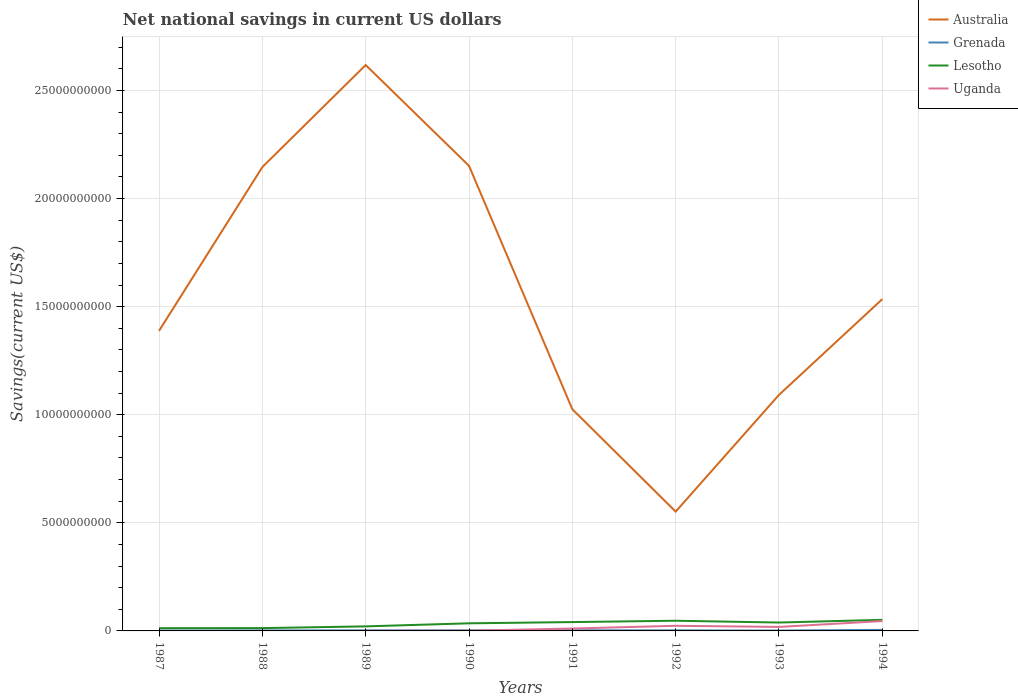Does the line corresponding to Australia intersect with the line corresponding to Uganda?
Give a very brief answer. No. Across all years, what is the maximum net national savings in Grenada?
Make the answer very short. 1.82e+07. What is the total net national savings in Grenada in the graph?
Keep it short and to the point. 7.77e+06. What is the difference between the highest and the second highest net national savings in Lesotho?
Keep it short and to the point. 3.85e+08. What is the difference between the highest and the lowest net national savings in Grenada?
Your response must be concise. 2. What is the difference between two consecutive major ticks on the Y-axis?
Provide a short and direct response. 5.00e+09. Are the values on the major ticks of Y-axis written in scientific E-notation?
Ensure brevity in your answer.  No. Does the graph contain grids?
Offer a terse response. Yes. Where does the legend appear in the graph?
Your response must be concise. Top right. How many legend labels are there?
Keep it short and to the point. 4. What is the title of the graph?
Your response must be concise. Net national savings in current US dollars. What is the label or title of the Y-axis?
Provide a succinct answer. Savings(current US$). What is the Savings(current US$) in Australia in 1987?
Ensure brevity in your answer.  1.39e+1. What is the Savings(current US$) in Grenada in 1987?
Provide a short and direct response. 1.85e+07. What is the Savings(current US$) of Lesotho in 1987?
Give a very brief answer. 1.28e+08. What is the Savings(current US$) of Uganda in 1987?
Your answer should be compact. 0. What is the Savings(current US$) of Australia in 1988?
Keep it short and to the point. 2.15e+1. What is the Savings(current US$) of Grenada in 1988?
Offer a terse response. 2.32e+07. What is the Savings(current US$) in Lesotho in 1988?
Provide a short and direct response. 1.30e+08. What is the Savings(current US$) of Uganda in 1988?
Your answer should be compact. 0. What is the Savings(current US$) of Australia in 1989?
Provide a succinct answer. 2.62e+1. What is the Savings(current US$) of Grenada in 1989?
Your answer should be compact. 2.59e+07. What is the Savings(current US$) of Lesotho in 1989?
Your answer should be compact. 2.10e+08. What is the Savings(current US$) of Uganda in 1989?
Give a very brief answer. 5.49e+06. What is the Savings(current US$) in Australia in 1990?
Offer a terse response. 2.15e+1. What is the Savings(current US$) in Grenada in 1990?
Provide a short and direct response. 2.65e+07. What is the Savings(current US$) of Lesotho in 1990?
Offer a very short reply. 3.52e+08. What is the Savings(current US$) in Uganda in 1990?
Your response must be concise. 1.02e+07. What is the Savings(current US$) of Australia in 1991?
Keep it short and to the point. 1.03e+1. What is the Savings(current US$) of Grenada in 1991?
Provide a short and direct response. 3.05e+07. What is the Savings(current US$) of Lesotho in 1991?
Provide a succinct answer. 4.09e+08. What is the Savings(current US$) in Uganda in 1991?
Your response must be concise. 1.10e+08. What is the Savings(current US$) of Australia in 1992?
Your answer should be compact. 5.52e+09. What is the Savings(current US$) of Grenada in 1992?
Your answer should be compact. 2.60e+07. What is the Savings(current US$) in Lesotho in 1992?
Provide a succinct answer. 4.71e+08. What is the Savings(current US$) of Uganda in 1992?
Keep it short and to the point. 2.37e+08. What is the Savings(current US$) in Australia in 1993?
Your response must be concise. 1.09e+1. What is the Savings(current US$) of Grenada in 1993?
Provide a short and direct response. 1.82e+07. What is the Savings(current US$) of Lesotho in 1993?
Offer a terse response. 3.88e+08. What is the Savings(current US$) in Uganda in 1993?
Make the answer very short. 1.85e+08. What is the Savings(current US$) of Australia in 1994?
Provide a short and direct response. 1.53e+1. What is the Savings(current US$) of Grenada in 1994?
Make the answer very short. 4.84e+07. What is the Savings(current US$) of Lesotho in 1994?
Offer a very short reply. 5.12e+08. What is the Savings(current US$) of Uganda in 1994?
Your answer should be compact. 4.56e+08. Across all years, what is the maximum Savings(current US$) in Australia?
Keep it short and to the point. 2.62e+1. Across all years, what is the maximum Savings(current US$) in Grenada?
Give a very brief answer. 4.84e+07. Across all years, what is the maximum Savings(current US$) in Lesotho?
Ensure brevity in your answer.  5.12e+08. Across all years, what is the maximum Savings(current US$) of Uganda?
Offer a very short reply. 4.56e+08. Across all years, what is the minimum Savings(current US$) in Australia?
Ensure brevity in your answer.  5.52e+09. Across all years, what is the minimum Savings(current US$) of Grenada?
Give a very brief answer. 1.82e+07. Across all years, what is the minimum Savings(current US$) in Lesotho?
Provide a succinct answer. 1.28e+08. Across all years, what is the minimum Savings(current US$) of Uganda?
Ensure brevity in your answer.  0. What is the total Savings(current US$) in Australia in the graph?
Provide a succinct answer. 1.25e+11. What is the total Savings(current US$) of Grenada in the graph?
Provide a short and direct response. 2.17e+08. What is the total Savings(current US$) in Lesotho in the graph?
Your answer should be compact. 2.60e+09. What is the total Savings(current US$) in Uganda in the graph?
Make the answer very short. 1.00e+09. What is the difference between the Savings(current US$) of Australia in 1987 and that in 1988?
Provide a short and direct response. -7.58e+09. What is the difference between the Savings(current US$) of Grenada in 1987 and that in 1988?
Offer a terse response. -4.69e+06. What is the difference between the Savings(current US$) in Lesotho in 1987 and that in 1988?
Make the answer very short. -2.21e+06. What is the difference between the Savings(current US$) in Australia in 1987 and that in 1989?
Ensure brevity in your answer.  -1.23e+1. What is the difference between the Savings(current US$) in Grenada in 1987 and that in 1989?
Make the answer very short. -7.41e+06. What is the difference between the Savings(current US$) in Lesotho in 1987 and that in 1989?
Ensure brevity in your answer.  -8.29e+07. What is the difference between the Savings(current US$) of Australia in 1987 and that in 1990?
Your answer should be compact. -7.63e+09. What is the difference between the Savings(current US$) of Grenada in 1987 and that in 1990?
Your answer should be compact. -8.00e+06. What is the difference between the Savings(current US$) in Lesotho in 1987 and that in 1990?
Make the answer very short. -2.24e+08. What is the difference between the Savings(current US$) in Australia in 1987 and that in 1991?
Your answer should be very brief. 3.62e+09. What is the difference between the Savings(current US$) in Grenada in 1987 and that in 1991?
Offer a terse response. -1.20e+07. What is the difference between the Savings(current US$) in Lesotho in 1987 and that in 1991?
Your answer should be very brief. -2.82e+08. What is the difference between the Savings(current US$) of Australia in 1987 and that in 1992?
Provide a short and direct response. 8.36e+09. What is the difference between the Savings(current US$) in Grenada in 1987 and that in 1992?
Give a very brief answer. -7.45e+06. What is the difference between the Savings(current US$) in Lesotho in 1987 and that in 1992?
Provide a succinct answer. -3.44e+08. What is the difference between the Savings(current US$) in Australia in 1987 and that in 1993?
Ensure brevity in your answer.  2.96e+09. What is the difference between the Savings(current US$) in Grenada in 1987 and that in 1993?
Your answer should be very brief. 3.14e+05. What is the difference between the Savings(current US$) of Lesotho in 1987 and that in 1993?
Offer a very short reply. -2.61e+08. What is the difference between the Savings(current US$) of Australia in 1987 and that in 1994?
Make the answer very short. -1.47e+09. What is the difference between the Savings(current US$) of Grenada in 1987 and that in 1994?
Offer a very short reply. -2.99e+07. What is the difference between the Savings(current US$) in Lesotho in 1987 and that in 1994?
Ensure brevity in your answer.  -3.85e+08. What is the difference between the Savings(current US$) in Australia in 1988 and that in 1989?
Provide a succinct answer. -4.72e+09. What is the difference between the Savings(current US$) of Grenada in 1988 and that in 1989?
Offer a terse response. -2.72e+06. What is the difference between the Savings(current US$) in Lesotho in 1988 and that in 1989?
Your answer should be very brief. -8.07e+07. What is the difference between the Savings(current US$) of Australia in 1988 and that in 1990?
Your answer should be compact. -5.80e+07. What is the difference between the Savings(current US$) in Grenada in 1988 and that in 1990?
Give a very brief answer. -3.31e+06. What is the difference between the Savings(current US$) of Lesotho in 1988 and that in 1990?
Provide a short and direct response. -2.22e+08. What is the difference between the Savings(current US$) in Australia in 1988 and that in 1991?
Your response must be concise. 1.12e+1. What is the difference between the Savings(current US$) in Grenada in 1988 and that in 1991?
Keep it short and to the point. -7.28e+06. What is the difference between the Savings(current US$) in Lesotho in 1988 and that in 1991?
Your answer should be compact. -2.80e+08. What is the difference between the Savings(current US$) in Australia in 1988 and that in 1992?
Your answer should be compact. 1.59e+1. What is the difference between the Savings(current US$) of Grenada in 1988 and that in 1992?
Your answer should be compact. -2.76e+06. What is the difference between the Savings(current US$) of Lesotho in 1988 and that in 1992?
Keep it short and to the point. -3.42e+08. What is the difference between the Savings(current US$) in Australia in 1988 and that in 1993?
Give a very brief answer. 1.05e+1. What is the difference between the Savings(current US$) in Grenada in 1988 and that in 1993?
Provide a short and direct response. 5.00e+06. What is the difference between the Savings(current US$) of Lesotho in 1988 and that in 1993?
Your answer should be very brief. -2.59e+08. What is the difference between the Savings(current US$) of Australia in 1988 and that in 1994?
Ensure brevity in your answer.  6.11e+09. What is the difference between the Savings(current US$) of Grenada in 1988 and that in 1994?
Offer a very short reply. -2.52e+07. What is the difference between the Savings(current US$) of Lesotho in 1988 and that in 1994?
Keep it short and to the point. -3.83e+08. What is the difference between the Savings(current US$) of Australia in 1989 and that in 1990?
Your answer should be compact. 4.66e+09. What is the difference between the Savings(current US$) of Grenada in 1989 and that in 1990?
Ensure brevity in your answer.  -5.96e+05. What is the difference between the Savings(current US$) of Lesotho in 1989 and that in 1990?
Keep it short and to the point. -1.41e+08. What is the difference between the Savings(current US$) in Uganda in 1989 and that in 1990?
Your answer should be very brief. -4.75e+06. What is the difference between the Savings(current US$) of Australia in 1989 and that in 1991?
Keep it short and to the point. 1.59e+1. What is the difference between the Savings(current US$) in Grenada in 1989 and that in 1991?
Your response must be concise. -4.56e+06. What is the difference between the Savings(current US$) of Lesotho in 1989 and that in 1991?
Offer a terse response. -1.99e+08. What is the difference between the Savings(current US$) in Uganda in 1989 and that in 1991?
Your response must be concise. -1.05e+08. What is the difference between the Savings(current US$) of Australia in 1989 and that in 1992?
Provide a succinct answer. 2.07e+1. What is the difference between the Savings(current US$) in Grenada in 1989 and that in 1992?
Offer a terse response. -4.77e+04. What is the difference between the Savings(current US$) in Lesotho in 1989 and that in 1992?
Ensure brevity in your answer.  -2.61e+08. What is the difference between the Savings(current US$) of Uganda in 1989 and that in 1992?
Offer a very short reply. -2.31e+08. What is the difference between the Savings(current US$) in Australia in 1989 and that in 1993?
Provide a succinct answer. 1.53e+1. What is the difference between the Savings(current US$) of Grenada in 1989 and that in 1993?
Ensure brevity in your answer.  7.72e+06. What is the difference between the Savings(current US$) in Lesotho in 1989 and that in 1993?
Offer a terse response. -1.78e+08. What is the difference between the Savings(current US$) in Uganda in 1989 and that in 1993?
Make the answer very short. -1.79e+08. What is the difference between the Savings(current US$) in Australia in 1989 and that in 1994?
Make the answer very short. 1.08e+1. What is the difference between the Savings(current US$) of Grenada in 1989 and that in 1994?
Keep it short and to the point. -2.25e+07. What is the difference between the Savings(current US$) in Lesotho in 1989 and that in 1994?
Provide a short and direct response. -3.02e+08. What is the difference between the Savings(current US$) in Uganda in 1989 and that in 1994?
Ensure brevity in your answer.  -4.51e+08. What is the difference between the Savings(current US$) of Australia in 1990 and that in 1991?
Provide a short and direct response. 1.13e+1. What is the difference between the Savings(current US$) in Grenada in 1990 and that in 1991?
Your answer should be very brief. -3.96e+06. What is the difference between the Savings(current US$) of Lesotho in 1990 and that in 1991?
Give a very brief answer. -5.76e+07. What is the difference between the Savings(current US$) in Uganda in 1990 and that in 1991?
Offer a very short reply. -1.00e+08. What is the difference between the Savings(current US$) of Australia in 1990 and that in 1992?
Make the answer very short. 1.60e+1. What is the difference between the Savings(current US$) of Grenada in 1990 and that in 1992?
Provide a succinct answer. 5.48e+05. What is the difference between the Savings(current US$) in Lesotho in 1990 and that in 1992?
Make the answer very short. -1.20e+08. What is the difference between the Savings(current US$) in Uganda in 1990 and that in 1992?
Your response must be concise. -2.26e+08. What is the difference between the Savings(current US$) of Australia in 1990 and that in 1993?
Your answer should be compact. 1.06e+1. What is the difference between the Savings(current US$) in Grenada in 1990 and that in 1993?
Your response must be concise. 8.32e+06. What is the difference between the Savings(current US$) of Lesotho in 1990 and that in 1993?
Your response must be concise. -3.65e+07. What is the difference between the Savings(current US$) of Uganda in 1990 and that in 1993?
Make the answer very short. -1.74e+08. What is the difference between the Savings(current US$) in Australia in 1990 and that in 1994?
Offer a terse response. 6.17e+09. What is the difference between the Savings(current US$) in Grenada in 1990 and that in 1994?
Offer a terse response. -2.19e+07. What is the difference between the Savings(current US$) in Lesotho in 1990 and that in 1994?
Your answer should be very brief. -1.61e+08. What is the difference between the Savings(current US$) in Uganda in 1990 and that in 1994?
Provide a short and direct response. -4.46e+08. What is the difference between the Savings(current US$) of Australia in 1991 and that in 1992?
Offer a terse response. 4.74e+09. What is the difference between the Savings(current US$) of Grenada in 1991 and that in 1992?
Provide a succinct answer. 4.51e+06. What is the difference between the Savings(current US$) in Lesotho in 1991 and that in 1992?
Provide a short and direct response. -6.21e+07. What is the difference between the Savings(current US$) in Uganda in 1991 and that in 1992?
Make the answer very short. -1.26e+08. What is the difference between the Savings(current US$) of Australia in 1991 and that in 1993?
Ensure brevity in your answer.  -6.64e+08. What is the difference between the Savings(current US$) of Grenada in 1991 and that in 1993?
Give a very brief answer. 1.23e+07. What is the difference between the Savings(current US$) of Lesotho in 1991 and that in 1993?
Ensure brevity in your answer.  2.10e+07. What is the difference between the Savings(current US$) in Uganda in 1991 and that in 1993?
Provide a short and direct response. -7.42e+07. What is the difference between the Savings(current US$) of Australia in 1991 and that in 1994?
Offer a terse response. -5.09e+09. What is the difference between the Savings(current US$) in Grenada in 1991 and that in 1994?
Make the answer very short. -1.79e+07. What is the difference between the Savings(current US$) in Lesotho in 1991 and that in 1994?
Give a very brief answer. -1.03e+08. What is the difference between the Savings(current US$) of Uganda in 1991 and that in 1994?
Make the answer very short. -3.46e+08. What is the difference between the Savings(current US$) in Australia in 1992 and that in 1993?
Your answer should be very brief. -5.40e+09. What is the difference between the Savings(current US$) in Grenada in 1992 and that in 1993?
Your response must be concise. 7.77e+06. What is the difference between the Savings(current US$) of Lesotho in 1992 and that in 1993?
Keep it short and to the point. 8.32e+07. What is the difference between the Savings(current US$) in Uganda in 1992 and that in 1993?
Offer a terse response. 5.19e+07. What is the difference between the Savings(current US$) of Australia in 1992 and that in 1994?
Ensure brevity in your answer.  -9.83e+09. What is the difference between the Savings(current US$) of Grenada in 1992 and that in 1994?
Your response must be concise. -2.24e+07. What is the difference between the Savings(current US$) of Lesotho in 1992 and that in 1994?
Your answer should be very brief. -4.09e+07. What is the difference between the Savings(current US$) of Uganda in 1992 and that in 1994?
Offer a very short reply. -2.20e+08. What is the difference between the Savings(current US$) in Australia in 1993 and that in 1994?
Make the answer very short. -4.43e+09. What is the difference between the Savings(current US$) in Grenada in 1993 and that in 1994?
Offer a very short reply. -3.02e+07. What is the difference between the Savings(current US$) of Lesotho in 1993 and that in 1994?
Give a very brief answer. -1.24e+08. What is the difference between the Savings(current US$) in Uganda in 1993 and that in 1994?
Ensure brevity in your answer.  -2.72e+08. What is the difference between the Savings(current US$) in Australia in 1987 and the Savings(current US$) in Grenada in 1988?
Provide a succinct answer. 1.39e+1. What is the difference between the Savings(current US$) of Australia in 1987 and the Savings(current US$) of Lesotho in 1988?
Provide a short and direct response. 1.37e+1. What is the difference between the Savings(current US$) in Grenada in 1987 and the Savings(current US$) in Lesotho in 1988?
Keep it short and to the point. -1.11e+08. What is the difference between the Savings(current US$) in Australia in 1987 and the Savings(current US$) in Grenada in 1989?
Ensure brevity in your answer.  1.39e+1. What is the difference between the Savings(current US$) in Australia in 1987 and the Savings(current US$) in Lesotho in 1989?
Keep it short and to the point. 1.37e+1. What is the difference between the Savings(current US$) of Australia in 1987 and the Savings(current US$) of Uganda in 1989?
Keep it short and to the point. 1.39e+1. What is the difference between the Savings(current US$) in Grenada in 1987 and the Savings(current US$) in Lesotho in 1989?
Make the answer very short. -1.92e+08. What is the difference between the Savings(current US$) in Grenada in 1987 and the Savings(current US$) in Uganda in 1989?
Keep it short and to the point. 1.30e+07. What is the difference between the Savings(current US$) of Lesotho in 1987 and the Savings(current US$) of Uganda in 1989?
Your response must be concise. 1.22e+08. What is the difference between the Savings(current US$) of Australia in 1987 and the Savings(current US$) of Grenada in 1990?
Your answer should be very brief. 1.39e+1. What is the difference between the Savings(current US$) in Australia in 1987 and the Savings(current US$) in Lesotho in 1990?
Your answer should be compact. 1.35e+1. What is the difference between the Savings(current US$) of Australia in 1987 and the Savings(current US$) of Uganda in 1990?
Keep it short and to the point. 1.39e+1. What is the difference between the Savings(current US$) of Grenada in 1987 and the Savings(current US$) of Lesotho in 1990?
Keep it short and to the point. -3.33e+08. What is the difference between the Savings(current US$) in Grenada in 1987 and the Savings(current US$) in Uganda in 1990?
Provide a short and direct response. 8.27e+06. What is the difference between the Savings(current US$) in Lesotho in 1987 and the Savings(current US$) in Uganda in 1990?
Provide a short and direct response. 1.17e+08. What is the difference between the Savings(current US$) of Australia in 1987 and the Savings(current US$) of Grenada in 1991?
Your answer should be compact. 1.38e+1. What is the difference between the Savings(current US$) of Australia in 1987 and the Savings(current US$) of Lesotho in 1991?
Your answer should be compact. 1.35e+1. What is the difference between the Savings(current US$) of Australia in 1987 and the Savings(current US$) of Uganda in 1991?
Provide a short and direct response. 1.38e+1. What is the difference between the Savings(current US$) in Grenada in 1987 and the Savings(current US$) in Lesotho in 1991?
Your response must be concise. -3.91e+08. What is the difference between the Savings(current US$) of Grenada in 1987 and the Savings(current US$) of Uganda in 1991?
Your answer should be very brief. -9.20e+07. What is the difference between the Savings(current US$) of Lesotho in 1987 and the Savings(current US$) of Uganda in 1991?
Provide a succinct answer. 1.70e+07. What is the difference between the Savings(current US$) in Australia in 1987 and the Savings(current US$) in Grenada in 1992?
Your response must be concise. 1.39e+1. What is the difference between the Savings(current US$) in Australia in 1987 and the Savings(current US$) in Lesotho in 1992?
Offer a very short reply. 1.34e+1. What is the difference between the Savings(current US$) in Australia in 1987 and the Savings(current US$) in Uganda in 1992?
Offer a terse response. 1.36e+1. What is the difference between the Savings(current US$) in Grenada in 1987 and the Savings(current US$) in Lesotho in 1992?
Provide a short and direct response. -4.53e+08. What is the difference between the Savings(current US$) of Grenada in 1987 and the Savings(current US$) of Uganda in 1992?
Ensure brevity in your answer.  -2.18e+08. What is the difference between the Savings(current US$) of Lesotho in 1987 and the Savings(current US$) of Uganda in 1992?
Give a very brief answer. -1.09e+08. What is the difference between the Savings(current US$) of Australia in 1987 and the Savings(current US$) of Grenada in 1993?
Ensure brevity in your answer.  1.39e+1. What is the difference between the Savings(current US$) in Australia in 1987 and the Savings(current US$) in Lesotho in 1993?
Your response must be concise. 1.35e+1. What is the difference between the Savings(current US$) in Australia in 1987 and the Savings(current US$) in Uganda in 1993?
Your answer should be very brief. 1.37e+1. What is the difference between the Savings(current US$) in Grenada in 1987 and the Savings(current US$) in Lesotho in 1993?
Provide a short and direct response. -3.70e+08. What is the difference between the Savings(current US$) in Grenada in 1987 and the Savings(current US$) in Uganda in 1993?
Provide a short and direct response. -1.66e+08. What is the difference between the Savings(current US$) in Lesotho in 1987 and the Savings(current US$) in Uganda in 1993?
Provide a succinct answer. -5.72e+07. What is the difference between the Savings(current US$) in Australia in 1987 and the Savings(current US$) in Grenada in 1994?
Offer a very short reply. 1.38e+1. What is the difference between the Savings(current US$) in Australia in 1987 and the Savings(current US$) in Lesotho in 1994?
Your answer should be very brief. 1.34e+1. What is the difference between the Savings(current US$) of Australia in 1987 and the Savings(current US$) of Uganda in 1994?
Offer a very short reply. 1.34e+1. What is the difference between the Savings(current US$) of Grenada in 1987 and the Savings(current US$) of Lesotho in 1994?
Ensure brevity in your answer.  -4.94e+08. What is the difference between the Savings(current US$) of Grenada in 1987 and the Savings(current US$) of Uganda in 1994?
Make the answer very short. -4.38e+08. What is the difference between the Savings(current US$) of Lesotho in 1987 and the Savings(current US$) of Uganda in 1994?
Provide a short and direct response. -3.29e+08. What is the difference between the Savings(current US$) of Australia in 1988 and the Savings(current US$) of Grenada in 1989?
Your response must be concise. 2.14e+1. What is the difference between the Savings(current US$) of Australia in 1988 and the Savings(current US$) of Lesotho in 1989?
Your answer should be compact. 2.12e+1. What is the difference between the Savings(current US$) of Australia in 1988 and the Savings(current US$) of Uganda in 1989?
Provide a succinct answer. 2.14e+1. What is the difference between the Savings(current US$) of Grenada in 1988 and the Savings(current US$) of Lesotho in 1989?
Offer a very short reply. -1.87e+08. What is the difference between the Savings(current US$) in Grenada in 1988 and the Savings(current US$) in Uganda in 1989?
Offer a very short reply. 1.77e+07. What is the difference between the Savings(current US$) in Lesotho in 1988 and the Savings(current US$) in Uganda in 1989?
Ensure brevity in your answer.  1.24e+08. What is the difference between the Savings(current US$) of Australia in 1988 and the Savings(current US$) of Grenada in 1990?
Offer a very short reply. 2.14e+1. What is the difference between the Savings(current US$) in Australia in 1988 and the Savings(current US$) in Lesotho in 1990?
Your response must be concise. 2.11e+1. What is the difference between the Savings(current US$) of Australia in 1988 and the Savings(current US$) of Uganda in 1990?
Your answer should be compact. 2.14e+1. What is the difference between the Savings(current US$) of Grenada in 1988 and the Savings(current US$) of Lesotho in 1990?
Offer a terse response. -3.28e+08. What is the difference between the Savings(current US$) of Grenada in 1988 and the Savings(current US$) of Uganda in 1990?
Your answer should be compact. 1.30e+07. What is the difference between the Savings(current US$) of Lesotho in 1988 and the Savings(current US$) of Uganda in 1990?
Ensure brevity in your answer.  1.19e+08. What is the difference between the Savings(current US$) of Australia in 1988 and the Savings(current US$) of Grenada in 1991?
Provide a short and direct response. 2.14e+1. What is the difference between the Savings(current US$) in Australia in 1988 and the Savings(current US$) in Lesotho in 1991?
Make the answer very short. 2.10e+1. What is the difference between the Savings(current US$) in Australia in 1988 and the Savings(current US$) in Uganda in 1991?
Provide a succinct answer. 2.13e+1. What is the difference between the Savings(current US$) of Grenada in 1988 and the Savings(current US$) of Lesotho in 1991?
Your answer should be compact. -3.86e+08. What is the difference between the Savings(current US$) in Grenada in 1988 and the Savings(current US$) in Uganda in 1991?
Your response must be concise. -8.73e+07. What is the difference between the Savings(current US$) in Lesotho in 1988 and the Savings(current US$) in Uganda in 1991?
Your answer should be very brief. 1.92e+07. What is the difference between the Savings(current US$) in Australia in 1988 and the Savings(current US$) in Grenada in 1992?
Provide a succinct answer. 2.14e+1. What is the difference between the Savings(current US$) in Australia in 1988 and the Savings(current US$) in Lesotho in 1992?
Offer a very short reply. 2.10e+1. What is the difference between the Savings(current US$) of Australia in 1988 and the Savings(current US$) of Uganda in 1992?
Offer a very short reply. 2.12e+1. What is the difference between the Savings(current US$) in Grenada in 1988 and the Savings(current US$) in Lesotho in 1992?
Your response must be concise. -4.48e+08. What is the difference between the Savings(current US$) in Grenada in 1988 and the Savings(current US$) in Uganda in 1992?
Offer a terse response. -2.13e+08. What is the difference between the Savings(current US$) of Lesotho in 1988 and the Savings(current US$) of Uganda in 1992?
Offer a very short reply. -1.07e+08. What is the difference between the Savings(current US$) of Australia in 1988 and the Savings(current US$) of Grenada in 1993?
Your response must be concise. 2.14e+1. What is the difference between the Savings(current US$) in Australia in 1988 and the Savings(current US$) in Lesotho in 1993?
Your response must be concise. 2.11e+1. What is the difference between the Savings(current US$) of Australia in 1988 and the Savings(current US$) of Uganda in 1993?
Provide a succinct answer. 2.13e+1. What is the difference between the Savings(current US$) in Grenada in 1988 and the Savings(current US$) in Lesotho in 1993?
Give a very brief answer. -3.65e+08. What is the difference between the Savings(current US$) in Grenada in 1988 and the Savings(current US$) in Uganda in 1993?
Your answer should be compact. -1.61e+08. What is the difference between the Savings(current US$) in Lesotho in 1988 and the Savings(current US$) in Uganda in 1993?
Make the answer very short. -5.49e+07. What is the difference between the Savings(current US$) of Australia in 1988 and the Savings(current US$) of Grenada in 1994?
Provide a succinct answer. 2.14e+1. What is the difference between the Savings(current US$) of Australia in 1988 and the Savings(current US$) of Lesotho in 1994?
Make the answer very short. 2.09e+1. What is the difference between the Savings(current US$) in Australia in 1988 and the Savings(current US$) in Uganda in 1994?
Give a very brief answer. 2.10e+1. What is the difference between the Savings(current US$) of Grenada in 1988 and the Savings(current US$) of Lesotho in 1994?
Offer a very short reply. -4.89e+08. What is the difference between the Savings(current US$) of Grenada in 1988 and the Savings(current US$) of Uganda in 1994?
Give a very brief answer. -4.33e+08. What is the difference between the Savings(current US$) in Lesotho in 1988 and the Savings(current US$) in Uganda in 1994?
Give a very brief answer. -3.27e+08. What is the difference between the Savings(current US$) of Australia in 1989 and the Savings(current US$) of Grenada in 1990?
Give a very brief answer. 2.61e+1. What is the difference between the Savings(current US$) in Australia in 1989 and the Savings(current US$) in Lesotho in 1990?
Give a very brief answer. 2.58e+1. What is the difference between the Savings(current US$) of Australia in 1989 and the Savings(current US$) of Uganda in 1990?
Your answer should be compact. 2.62e+1. What is the difference between the Savings(current US$) in Grenada in 1989 and the Savings(current US$) in Lesotho in 1990?
Give a very brief answer. -3.26e+08. What is the difference between the Savings(current US$) of Grenada in 1989 and the Savings(current US$) of Uganda in 1990?
Make the answer very short. 1.57e+07. What is the difference between the Savings(current US$) of Lesotho in 1989 and the Savings(current US$) of Uganda in 1990?
Offer a very short reply. 2.00e+08. What is the difference between the Savings(current US$) of Australia in 1989 and the Savings(current US$) of Grenada in 1991?
Offer a very short reply. 2.61e+1. What is the difference between the Savings(current US$) in Australia in 1989 and the Savings(current US$) in Lesotho in 1991?
Offer a terse response. 2.58e+1. What is the difference between the Savings(current US$) in Australia in 1989 and the Savings(current US$) in Uganda in 1991?
Your response must be concise. 2.61e+1. What is the difference between the Savings(current US$) in Grenada in 1989 and the Savings(current US$) in Lesotho in 1991?
Give a very brief answer. -3.83e+08. What is the difference between the Savings(current US$) in Grenada in 1989 and the Savings(current US$) in Uganda in 1991?
Ensure brevity in your answer.  -8.46e+07. What is the difference between the Savings(current US$) of Lesotho in 1989 and the Savings(current US$) of Uganda in 1991?
Provide a short and direct response. 9.99e+07. What is the difference between the Savings(current US$) of Australia in 1989 and the Savings(current US$) of Grenada in 1992?
Offer a very short reply. 2.61e+1. What is the difference between the Savings(current US$) in Australia in 1989 and the Savings(current US$) in Lesotho in 1992?
Provide a succinct answer. 2.57e+1. What is the difference between the Savings(current US$) in Australia in 1989 and the Savings(current US$) in Uganda in 1992?
Keep it short and to the point. 2.59e+1. What is the difference between the Savings(current US$) of Grenada in 1989 and the Savings(current US$) of Lesotho in 1992?
Keep it short and to the point. -4.45e+08. What is the difference between the Savings(current US$) of Grenada in 1989 and the Savings(current US$) of Uganda in 1992?
Provide a short and direct response. -2.11e+08. What is the difference between the Savings(current US$) in Lesotho in 1989 and the Savings(current US$) in Uganda in 1992?
Give a very brief answer. -2.62e+07. What is the difference between the Savings(current US$) of Australia in 1989 and the Savings(current US$) of Grenada in 1993?
Provide a short and direct response. 2.62e+1. What is the difference between the Savings(current US$) in Australia in 1989 and the Savings(current US$) in Lesotho in 1993?
Make the answer very short. 2.58e+1. What is the difference between the Savings(current US$) of Australia in 1989 and the Savings(current US$) of Uganda in 1993?
Make the answer very short. 2.60e+1. What is the difference between the Savings(current US$) in Grenada in 1989 and the Savings(current US$) in Lesotho in 1993?
Provide a short and direct response. -3.62e+08. What is the difference between the Savings(current US$) in Grenada in 1989 and the Savings(current US$) in Uganda in 1993?
Your answer should be very brief. -1.59e+08. What is the difference between the Savings(current US$) in Lesotho in 1989 and the Savings(current US$) in Uganda in 1993?
Make the answer very short. 2.57e+07. What is the difference between the Savings(current US$) in Australia in 1989 and the Savings(current US$) in Grenada in 1994?
Your answer should be very brief. 2.61e+1. What is the difference between the Savings(current US$) of Australia in 1989 and the Savings(current US$) of Lesotho in 1994?
Your answer should be compact. 2.57e+1. What is the difference between the Savings(current US$) in Australia in 1989 and the Savings(current US$) in Uganda in 1994?
Provide a short and direct response. 2.57e+1. What is the difference between the Savings(current US$) in Grenada in 1989 and the Savings(current US$) in Lesotho in 1994?
Offer a terse response. -4.86e+08. What is the difference between the Savings(current US$) in Grenada in 1989 and the Savings(current US$) in Uganda in 1994?
Provide a succinct answer. -4.30e+08. What is the difference between the Savings(current US$) of Lesotho in 1989 and the Savings(current US$) of Uganda in 1994?
Your answer should be very brief. -2.46e+08. What is the difference between the Savings(current US$) in Australia in 1990 and the Savings(current US$) in Grenada in 1991?
Give a very brief answer. 2.15e+1. What is the difference between the Savings(current US$) in Australia in 1990 and the Savings(current US$) in Lesotho in 1991?
Your answer should be very brief. 2.11e+1. What is the difference between the Savings(current US$) of Australia in 1990 and the Savings(current US$) of Uganda in 1991?
Your answer should be very brief. 2.14e+1. What is the difference between the Savings(current US$) of Grenada in 1990 and the Savings(current US$) of Lesotho in 1991?
Your answer should be compact. -3.83e+08. What is the difference between the Savings(current US$) in Grenada in 1990 and the Savings(current US$) in Uganda in 1991?
Your answer should be very brief. -8.40e+07. What is the difference between the Savings(current US$) in Lesotho in 1990 and the Savings(current US$) in Uganda in 1991?
Your answer should be compact. 2.41e+08. What is the difference between the Savings(current US$) in Australia in 1990 and the Savings(current US$) in Grenada in 1992?
Give a very brief answer. 2.15e+1. What is the difference between the Savings(current US$) of Australia in 1990 and the Savings(current US$) of Lesotho in 1992?
Provide a short and direct response. 2.10e+1. What is the difference between the Savings(current US$) in Australia in 1990 and the Savings(current US$) in Uganda in 1992?
Provide a succinct answer. 2.13e+1. What is the difference between the Savings(current US$) in Grenada in 1990 and the Savings(current US$) in Lesotho in 1992?
Offer a terse response. -4.45e+08. What is the difference between the Savings(current US$) of Grenada in 1990 and the Savings(current US$) of Uganda in 1992?
Your response must be concise. -2.10e+08. What is the difference between the Savings(current US$) in Lesotho in 1990 and the Savings(current US$) in Uganda in 1992?
Your response must be concise. 1.15e+08. What is the difference between the Savings(current US$) of Australia in 1990 and the Savings(current US$) of Grenada in 1993?
Make the answer very short. 2.15e+1. What is the difference between the Savings(current US$) of Australia in 1990 and the Savings(current US$) of Lesotho in 1993?
Offer a very short reply. 2.11e+1. What is the difference between the Savings(current US$) in Australia in 1990 and the Savings(current US$) in Uganda in 1993?
Your answer should be compact. 2.13e+1. What is the difference between the Savings(current US$) in Grenada in 1990 and the Savings(current US$) in Lesotho in 1993?
Offer a very short reply. -3.62e+08. What is the difference between the Savings(current US$) of Grenada in 1990 and the Savings(current US$) of Uganda in 1993?
Provide a short and direct response. -1.58e+08. What is the difference between the Savings(current US$) in Lesotho in 1990 and the Savings(current US$) in Uganda in 1993?
Provide a short and direct response. 1.67e+08. What is the difference between the Savings(current US$) of Australia in 1990 and the Savings(current US$) of Grenada in 1994?
Your answer should be very brief. 2.15e+1. What is the difference between the Savings(current US$) of Australia in 1990 and the Savings(current US$) of Lesotho in 1994?
Offer a terse response. 2.10e+1. What is the difference between the Savings(current US$) in Australia in 1990 and the Savings(current US$) in Uganda in 1994?
Your answer should be very brief. 2.11e+1. What is the difference between the Savings(current US$) in Grenada in 1990 and the Savings(current US$) in Lesotho in 1994?
Your response must be concise. -4.86e+08. What is the difference between the Savings(current US$) in Grenada in 1990 and the Savings(current US$) in Uganda in 1994?
Your response must be concise. -4.30e+08. What is the difference between the Savings(current US$) of Lesotho in 1990 and the Savings(current US$) of Uganda in 1994?
Your answer should be compact. -1.05e+08. What is the difference between the Savings(current US$) in Australia in 1991 and the Savings(current US$) in Grenada in 1992?
Make the answer very short. 1.02e+1. What is the difference between the Savings(current US$) of Australia in 1991 and the Savings(current US$) of Lesotho in 1992?
Give a very brief answer. 9.78e+09. What is the difference between the Savings(current US$) in Australia in 1991 and the Savings(current US$) in Uganda in 1992?
Provide a succinct answer. 1.00e+1. What is the difference between the Savings(current US$) of Grenada in 1991 and the Savings(current US$) of Lesotho in 1992?
Your response must be concise. -4.41e+08. What is the difference between the Savings(current US$) in Grenada in 1991 and the Savings(current US$) in Uganda in 1992?
Make the answer very short. -2.06e+08. What is the difference between the Savings(current US$) in Lesotho in 1991 and the Savings(current US$) in Uganda in 1992?
Your answer should be compact. 1.73e+08. What is the difference between the Savings(current US$) in Australia in 1991 and the Savings(current US$) in Grenada in 1993?
Keep it short and to the point. 1.02e+1. What is the difference between the Savings(current US$) of Australia in 1991 and the Savings(current US$) of Lesotho in 1993?
Provide a succinct answer. 9.87e+09. What is the difference between the Savings(current US$) of Australia in 1991 and the Savings(current US$) of Uganda in 1993?
Your answer should be compact. 1.01e+1. What is the difference between the Savings(current US$) in Grenada in 1991 and the Savings(current US$) in Lesotho in 1993?
Your answer should be very brief. -3.58e+08. What is the difference between the Savings(current US$) of Grenada in 1991 and the Savings(current US$) of Uganda in 1993?
Your answer should be very brief. -1.54e+08. What is the difference between the Savings(current US$) of Lesotho in 1991 and the Savings(current US$) of Uganda in 1993?
Keep it short and to the point. 2.25e+08. What is the difference between the Savings(current US$) in Australia in 1991 and the Savings(current US$) in Grenada in 1994?
Offer a terse response. 1.02e+1. What is the difference between the Savings(current US$) in Australia in 1991 and the Savings(current US$) in Lesotho in 1994?
Your response must be concise. 9.74e+09. What is the difference between the Savings(current US$) in Australia in 1991 and the Savings(current US$) in Uganda in 1994?
Provide a succinct answer. 9.80e+09. What is the difference between the Savings(current US$) in Grenada in 1991 and the Savings(current US$) in Lesotho in 1994?
Provide a short and direct response. -4.82e+08. What is the difference between the Savings(current US$) in Grenada in 1991 and the Savings(current US$) in Uganda in 1994?
Your response must be concise. -4.26e+08. What is the difference between the Savings(current US$) of Lesotho in 1991 and the Savings(current US$) of Uganda in 1994?
Keep it short and to the point. -4.70e+07. What is the difference between the Savings(current US$) in Australia in 1992 and the Savings(current US$) in Grenada in 1993?
Give a very brief answer. 5.50e+09. What is the difference between the Savings(current US$) in Australia in 1992 and the Savings(current US$) in Lesotho in 1993?
Make the answer very short. 5.13e+09. What is the difference between the Savings(current US$) in Australia in 1992 and the Savings(current US$) in Uganda in 1993?
Your answer should be compact. 5.33e+09. What is the difference between the Savings(current US$) in Grenada in 1992 and the Savings(current US$) in Lesotho in 1993?
Ensure brevity in your answer.  -3.62e+08. What is the difference between the Savings(current US$) of Grenada in 1992 and the Savings(current US$) of Uganda in 1993?
Your answer should be very brief. -1.59e+08. What is the difference between the Savings(current US$) of Lesotho in 1992 and the Savings(current US$) of Uganda in 1993?
Keep it short and to the point. 2.87e+08. What is the difference between the Savings(current US$) of Australia in 1992 and the Savings(current US$) of Grenada in 1994?
Your answer should be compact. 5.47e+09. What is the difference between the Savings(current US$) in Australia in 1992 and the Savings(current US$) in Lesotho in 1994?
Offer a very short reply. 5.01e+09. What is the difference between the Savings(current US$) in Australia in 1992 and the Savings(current US$) in Uganda in 1994?
Offer a terse response. 5.06e+09. What is the difference between the Savings(current US$) in Grenada in 1992 and the Savings(current US$) in Lesotho in 1994?
Give a very brief answer. -4.86e+08. What is the difference between the Savings(current US$) of Grenada in 1992 and the Savings(current US$) of Uganda in 1994?
Offer a very short reply. -4.30e+08. What is the difference between the Savings(current US$) in Lesotho in 1992 and the Savings(current US$) in Uganda in 1994?
Your response must be concise. 1.51e+07. What is the difference between the Savings(current US$) in Australia in 1993 and the Savings(current US$) in Grenada in 1994?
Offer a terse response. 1.09e+1. What is the difference between the Savings(current US$) of Australia in 1993 and the Savings(current US$) of Lesotho in 1994?
Offer a terse response. 1.04e+1. What is the difference between the Savings(current US$) in Australia in 1993 and the Savings(current US$) in Uganda in 1994?
Your answer should be compact. 1.05e+1. What is the difference between the Savings(current US$) in Grenada in 1993 and the Savings(current US$) in Lesotho in 1994?
Make the answer very short. -4.94e+08. What is the difference between the Savings(current US$) in Grenada in 1993 and the Savings(current US$) in Uganda in 1994?
Make the answer very short. -4.38e+08. What is the difference between the Savings(current US$) of Lesotho in 1993 and the Savings(current US$) of Uganda in 1994?
Provide a succinct answer. -6.80e+07. What is the average Savings(current US$) of Australia per year?
Keep it short and to the point. 1.56e+1. What is the average Savings(current US$) of Grenada per year?
Ensure brevity in your answer.  2.71e+07. What is the average Savings(current US$) of Lesotho per year?
Offer a very short reply. 3.25e+08. What is the average Savings(current US$) of Uganda per year?
Provide a short and direct response. 1.25e+08. In the year 1987, what is the difference between the Savings(current US$) of Australia and Savings(current US$) of Grenada?
Keep it short and to the point. 1.39e+1. In the year 1987, what is the difference between the Savings(current US$) in Australia and Savings(current US$) in Lesotho?
Provide a succinct answer. 1.38e+1. In the year 1987, what is the difference between the Savings(current US$) in Grenada and Savings(current US$) in Lesotho?
Your answer should be very brief. -1.09e+08. In the year 1988, what is the difference between the Savings(current US$) in Australia and Savings(current US$) in Grenada?
Your answer should be very brief. 2.14e+1. In the year 1988, what is the difference between the Savings(current US$) of Australia and Savings(current US$) of Lesotho?
Ensure brevity in your answer.  2.13e+1. In the year 1988, what is the difference between the Savings(current US$) in Grenada and Savings(current US$) in Lesotho?
Offer a very short reply. -1.07e+08. In the year 1989, what is the difference between the Savings(current US$) of Australia and Savings(current US$) of Grenada?
Your answer should be compact. 2.61e+1. In the year 1989, what is the difference between the Savings(current US$) of Australia and Savings(current US$) of Lesotho?
Provide a short and direct response. 2.60e+1. In the year 1989, what is the difference between the Savings(current US$) in Australia and Savings(current US$) in Uganda?
Your answer should be very brief. 2.62e+1. In the year 1989, what is the difference between the Savings(current US$) in Grenada and Savings(current US$) in Lesotho?
Provide a short and direct response. -1.84e+08. In the year 1989, what is the difference between the Savings(current US$) of Grenada and Savings(current US$) of Uganda?
Your response must be concise. 2.04e+07. In the year 1989, what is the difference between the Savings(current US$) in Lesotho and Savings(current US$) in Uganda?
Offer a terse response. 2.05e+08. In the year 1990, what is the difference between the Savings(current US$) in Australia and Savings(current US$) in Grenada?
Keep it short and to the point. 2.15e+1. In the year 1990, what is the difference between the Savings(current US$) in Australia and Savings(current US$) in Lesotho?
Your response must be concise. 2.12e+1. In the year 1990, what is the difference between the Savings(current US$) of Australia and Savings(current US$) of Uganda?
Your answer should be very brief. 2.15e+1. In the year 1990, what is the difference between the Savings(current US$) of Grenada and Savings(current US$) of Lesotho?
Provide a succinct answer. -3.25e+08. In the year 1990, what is the difference between the Savings(current US$) in Grenada and Savings(current US$) in Uganda?
Provide a succinct answer. 1.63e+07. In the year 1990, what is the difference between the Savings(current US$) in Lesotho and Savings(current US$) in Uganda?
Make the answer very short. 3.41e+08. In the year 1991, what is the difference between the Savings(current US$) in Australia and Savings(current US$) in Grenada?
Your response must be concise. 1.02e+1. In the year 1991, what is the difference between the Savings(current US$) of Australia and Savings(current US$) of Lesotho?
Make the answer very short. 9.84e+09. In the year 1991, what is the difference between the Savings(current US$) in Australia and Savings(current US$) in Uganda?
Your answer should be very brief. 1.01e+1. In the year 1991, what is the difference between the Savings(current US$) in Grenada and Savings(current US$) in Lesotho?
Your response must be concise. -3.79e+08. In the year 1991, what is the difference between the Savings(current US$) in Grenada and Savings(current US$) in Uganda?
Offer a terse response. -8.00e+07. In the year 1991, what is the difference between the Savings(current US$) in Lesotho and Savings(current US$) in Uganda?
Offer a very short reply. 2.99e+08. In the year 1992, what is the difference between the Savings(current US$) in Australia and Savings(current US$) in Grenada?
Your answer should be very brief. 5.49e+09. In the year 1992, what is the difference between the Savings(current US$) in Australia and Savings(current US$) in Lesotho?
Keep it short and to the point. 5.05e+09. In the year 1992, what is the difference between the Savings(current US$) in Australia and Savings(current US$) in Uganda?
Your answer should be compact. 5.28e+09. In the year 1992, what is the difference between the Savings(current US$) of Grenada and Savings(current US$) of Lesotho?
Give a very brief answer. -4.45e+08. In the year 1992, what is the difference between the Savings(current US$) in Grenada and Savings(current US$) in Uganda?
Keep it short and to the point. -2.11e+08. In the year 1992, what is the difference between the Savings(current US$) in Lesotho and Savings(current US$) in Uganda?
Offer a terse response. 2.35e+08. In the year 1993, what is the difference between the Savings(current US$) of Australia and Savings(current US$) of Grenada?
Keep it short and to the point. 1.09e+1. In the year 1993, what is the difference between the Savings(current US$) of Australia and Savings(current US$) of Lesotho?
Offer a very short reply. 1.05e+1. In the year 1993, what is the difference between the Savings(current US$) of Australia and Savings(current US$) of Uganda?
Keep it short and to the point. 1.07e+1. In the year 1993, what is the difference between the Savings(current US$) in Grenada and Savings(current US$) in Lesotho?
Keep it short and to the point. -3.70e+08. In the year 1993, what is the difference between the Savings(current US$) of Grenada and Savings(current US$) of Uganda?
Make the answer very short. -1.66e+08. In the year 1993, what is the difference between the Savings(current US$) in Lesotho and Savings(current US$) in Uganda?
Make the answer very short. 2.04e+08. In the year 1994, what is the difference between the Savings(current US$) of Australia and Savings(current US$) of Grenada?
Ensure brevity in your answer.  1.53e+1. In the year 1994, what is the difference between the Savings(current US$) of Australia and Savings(current US$) of Lesotho?
Provide a short and direct response. 1.48e+1. In the year 1994, what is the difference between the Savings(current US$) in Australia and Savings(current US$) in Uganda?
Provide a succinct answer. 1.49e+1. In the year 1994, what is the difference between the Savings(current US$) of Grenada and Savings(current US$) of Lesotho?
Keep it short and to the point. -4.64e+08. In the year 1994, what is the difference between the Savings(current US$) in Grenada and Savings(current US$) in Uganda?
Your answer should be very brief. -4.08e+08. In the year 1994, what is the difference between the Savings(current US$) in Lesotho and Savings(current US$) in Uganda?
Keep it short and to the point. 5.61e+07. What is the ratio of the Savings(current US$) of Australia in 1987 to that in 1988?
Offer a terse response. 0.65. What is the ratio of the Savings(current US$) in Grenada in 1987 to that in 1988?
Keep it short and to the point. 0.8. What is the ratio of the Savings(current US$) in Lesotho in 1987 to that in 1988?
Make the answer very short. 0.98. What is the ratio of the Savings(current US$) of Australia in 1987 to that in 1989?
Keep it short and to the point. 0.53. What is the ratio of the Savings(current US$) of Lesotho in 1987 to that in 1989?
Offer a very short reply. 0.61. What is the ratio of the Savings(current US$) of Australia in 1987 to that in 1990?
Offer a terse response. 0.65. What is the ratio of the Savings(current US$) in Grenada in 1987 to that in 1990?
Ensure brevity in your answer.  0.7. What is the ratio of the Savings(current US$) in Lesotho in 1987 to that in 1990?
Provide a succinct answer. 0.36. What is the ratio of the Savings(current US$) in Australia in 1987 to that in 1991?
Keep it short and to the point. 1.35. What is the ratio of the Savings(current US$) of Grenada in 1987 to that in 1991?
Provide a short and direct response. 0.61. What is the ratio of the Savings(current US$) in Lesotho in 1987 to that in 1991?
Your answer should be very brief. 0.31. What is the ratio of the Savings(current US$) in Australia in 1987 to that in 1992?
Make the answer very short. 2.51. What is the ratio of the Savings(current US$) of Grenada in 1987 to that in 1992?
Offer a very short reply. 0.71. What is the ratio of the Savings(current US$) in Lesotho in 1987 to that in 1992?
Your answer should be compact. 0.27. What is the ratio of the Savings(current US$) of Australia in 1987 to that in 1993?
Ensure brevity in your answer.  1.27. What is the ratio of the Savings(current US$) of Grenada in 1987 to that in 1993?
Keep it short and to the point. 1.02. What is the ratio of the Savings(current US$) in Lesotho in 1987 to that in 1993?
Give a very brief answer. 0.33. What is the ratio of the Savings(current US$) in Australia in 1987 to that in 1994?
Ensure brevity in your answer.  0.9. What is the ratio of the Savings(current US$) of Grenada in 1987 to that in 1994?
Offer a terse response. 0.38. What is the ratio of the Savings(current US$) in Lesotho in 1987 to that in 1994?
Offer a terse response. 0.25. What is the ratio of the Savings(current US$) of Australia in 1988 to that in 1989?
Keep it short and to the point. 0.82. What is the ratio of the Savings(current US$) in Grenada in 1988 to that in 1989?
Offer a terse response. 0.9. What is the ratio of the Savings(current US$) in Lesotho in 1988 to that in 1989?
Make the answer very short. 0.62. What is the ratio of the Savings(current US$) in Australia in 1988 to that in 1990?
Provide a succinct answer. 1. What is the ratio of the Savings(current US$) in Grenada in 1988 to that in 1990?
Offer a very short reply. 0.88. What is the ratio of the Savings(current US$) of Lesotho in 1988 to that in 1990?
Make the answer very short. 0.37. What is the ratio of the Savings(current US$) of Australia in 1988 to that in 1991?
Ensure brevity in your answer.  2.09. What is the ratio of the Savings(current US$) in Grenada in 1988 to that in 1991?
Make the answer very short. 0.76. What is the ratio of the Savings(current US$) of Lesotho in 1988 to that in 1991?
Make the answer very short. 0.32. What is the ratio of the Savings(current US$) of Australia in 1988 to that in 1992?
Make the answer very short. 3.89. What is the ratio of the Savings(current US$) in Grenada in 1988 to that in 1992?
Offer a terse response. 0.89. What is the ratio of the Savings(current US$) of Lesotho in 1988 to that in 1992?
Provide a short and direct response. 0.28. What is the ratio of the Savings(current US$) in Australia in 1988 to that in 1993?
Your response must be concise. 1.97. What is the ratio of the Savings(current US$) in Grenada in 1988 to that in 1993?
Ensure brevity in your answer.  1.27. What is the ratio of the Savings(current US$) in Lesotho in 1988 to that in 1993?
Keep it short and to the point. 0.33. What is the ratio of the Savings(current US$) of Australia in 1988 to that in 1994?
Your response must be concise. 1.4. What is the ratio of the Savings(current US$) of Grenada in 1988 to that in 1994?
Provide a succinct answer. 0.48. What is the ratio of the Savings(current US$) in Lesotho in 1988 to that in 1994?
Your response must be concise. 0.25. What is the ratio of the Savings(current US$) in Australia in 1989 to that in 1990?
Offer a very short reply. 1.22. What is the ratio of the Savings(current US$) in Grenada in 1989 to that in 1990?
Your response must be concise. 0.98. What is the ratio of the Savings(current US$) of Lesotho in 1989 to that in 1990?
Offer a terse response. 0.6. What is the ratio of the Savings(current US$) of Uganda in 1989 to that in 1990?
Provide a succinct answer. 0.54. What is the ratio of the Savings(current US$) in Australia in 1989 to that in 1991?
Keep it short and to the point. 2.55. What is the ratio of the Savings(current US$) in Grenada in 1989 to that in 1991?
Provide a succinct answer. 0.85. What is the ratio of the Savings(current US$) of Lesotho in 1989 to that in 1991?
Provide a short and direct response. 0.51. What is the ratio of the Savings(current US$) in Uganda in 1989 to that in 1991?
Give a very brief answer. 0.05. What is the ratio of the Savings(current US$) of Australia in 1989 to that in 1992?
Offer a terse response. 4.74. What is the ratio of the Savings(current US$) of Grenada in 1989 to that in 1992?
Your answer should be very brief. 1. What is the ratio of the Savings(current US$) in Lesotho in 1989 to that in 1992?
Keep it short and to the point. 0.45. What is the ratio of the Savings(current US$) in Uganda in 1989 to that in 1992?
Your answer should be compact. 0.02. What is the ratio of the Savings(current US$) of Australia in 1989 to that in 1993?
Ensure brevity in your answer.  2.4. What is the ratio of the Savings(current US$) of Grenada in 1989 to that in 1993?
Provide a short and direct response. 1.42. What is the ratio of the Savings(current US$) in Lesotho in 1989 to that in 1993?
Make the answer very short. 0.54. What is the ratio of the Savings(current US$) of Uganda in 1989 to that in 1993?
Your response must be concise. 0.03. What is the ratio of the Savings(current US$) in Australia in 1989 to that in 1994?
Provide a short and direct response. 1.71. What is the ratio of the Savings(current US$) of Grenada in 1989 to that in 1994?
Your response must be concise. 0.54. What is the ratio of the Savings(current US$) in Lesotho in 1989 to that in 1994?
Give a very brief answer. 0.41. What is the ratio of the Savings(current US$) of Uganda in 1989 to that in 1994?
Your answer should be very brief. 0.01. What is the ratio of the Savings(current US$) in Australia in 1990 to that in 1991?
Provide a succinct answer. 2.1. What is the ratio of the Savings(current US$) of Grenada in 1990 to that in 1991?
Provide a succinct answer. 0.87. What is the ratio of the Savings(current US$) of Lesotho in 1990 to that in 1991?
Provide a succinct answer. 0.86. What is the ratio of the Savings(current US$) of Uganda in 1990 to that in 1991?
Give a very brief answer. 0.09. What is the ratio of the Savings(current US$) in Australia in 1990 to that in 1992?
Ensure brevity in your answer.  3.9. What is the ratio of the Savings(current US$) in Grenada in 1990 to that in 1992?
Ensure brevity in your answer.  1.02. What is the ratio of the Savings(current US$) in Lesotho in 1990 to that in 1992?
Your answer should be very brief. 0.75. What is the ratio of the Savings(current US$) in Uganda in 1990 to that in 1992?
Keep it short and to the point. 0.04. What is the ratio of the Savings(current US$) of Australia in 1990 to that in 1993?
Your answer should be compact. 1.97. What is the ratio of the Savings(current US$) of Grenada in 1990 to that in 1993?
Give a very brief answer. 1.46. What is the ratio of the Savings(current US$) in Lesotho in 1990 to that in 1993?
Your answer should be very brief. 0.91. What is the ratio of the Savings(current US$) in Uganda in 1990 to that in 1993?
Ensure brevity in your answer.  0.06. What is the ratio of the Savings(current US$) in Australia in 1990 to that in 1994?
Give a very brief answer. 1.4. What is the ratio of the Savings(current US$) of Grenada in 1990 to that in 1994?
Offer a very short reply. 0.55. What is the ratio of the Savings(current US$) in Lesotho in 1990 to that in 1994?
Provide a succinct answer. 0.69. What is the ratio of the Savings(current US$) of Uganda in 1990 to that in 1994?
Your answer should be compact. 0.02. What is the ratio of the Savings(current US$) of Australia in 1991 to that in 1992?
Provide a short and direct response. 1.86. What is the ratio of the Savings(current US$) in Grenada in 1991 to that in 1992?
Your answer should be very brief. 1.17. What is the ratio of the Savings(current US$) of Lesotho in 1991 to that in 1992?
Your response must be concise. 0.87. What is the ratio of the Savings(current US$) in Uganda in 1991 to that in 1992?
Offer a terse response. 0.47. What is the ratio of the Savings(current US$) of Australia in 1991 to that in 1993?
Give a very brief answer. 0.94. What is the ratio of the Savings(current US$) of Grenada in 1991 to that in 1993?
Provide a short and direct response. 1.67. What is the ratio of the Savings(current US$) in Lesotho in 1991 to that in 1993?
Your answer should be compact. 1.05. What is the ratio of the Savings(current US$) of Uganda in 1991 to that in 1993?
Provide a short and direct response. 0.6. What is the ratio of the Savings(current US$) in Australia in 1991 to that in 1994?
Make the answer very short. 0.67. What is the ratio of the Savings(current US$) in Grenada in 1991 to that in 1994?
Ensure brevity in your answer.  0.63. What is the ratio of the Savings(current US$) in Lesotho in 1991 to that in 1994?
Provide a short and direct response. 0.8. What is the ratio of the Savings(current US$) in Uganda in 1991 to that in 1994?
Ensure brevity in your answer.  0.24. What is the ratio of the Savings(current US$) of Australia in 1992 to that in 1993?
Provide a short and direct response. 0.51. What is the ratio of the Savings(current US$) in Grenada in 1992 to that in 1993?
Keep it short and to the point. 1.43. What is the ratio of the Savings(current US$) in Lesotho in 1992 to that in 1993?
Make the answer very short. 1.21. What is the ratio of the Savings(current US$) in Uganda in 1992 to that in 1993?
Make the answer very short. 1.28. What is the ratio of the Savings(current US$) of Australia in 1992 to that in 1994?
Provide a short and direct response. 0.36. What is the ratio of the Savings(current US$) in Grenada in 1992 to that in 1994?
Your answer should be compact. 0.54. What is the ratio of the Savings(current US$) of Lesotho in 1992 to that in 1994?
Your answer should be compact. 0.92. What is the ratio of the Savings(current US$) of Uganda in 1992 to that in 1994?
Make the answer very short. 0.52. What is the ratio of the Savings(current US$) of Australia in 1993 to that in 1994?
Give a very brief answer. 0.71. What is the ratio of the Savings(current US$) of Grenada in 1993 to that in 1994?
Your answer should be compact. 0.38. What is the ratio of the Savings(current US$) in Lesotho in 1993 to that in 1994?
Provide a succinct answer. 0.76. What is the ratio of the Savings(current US$) of Uganda in 1993 to that in 1994?
Your answer should be compact. 0.4. What is the difference between the highest and the second highest Savings(current US$) in Australia?
Offer a very short reply. 4.66e+09. What is the difference between the highest and the second highest Savings(current US$) of Grenada?
Ensure brevity in your answer.  1.79e+07. What is the difference between the highest and the second highest Savings(current US$) in Lesotho?
Your answer should be very brief. 4.09e+07. What is the difference between the highest and the second highest Savings(current US$) of Uganda?
Provide a succinct answer. 2.20e+08. What is the difference between the highest and the lowest Savings(current US$) of Australia?
Keep it short and to the point. 2.07e+1. What is the difference between the highest and the lowest Savings(current US$) of Grenada?
Make the answer very short. 3.02e+07. What is the difference between the highest and the lowest Savings(current US$) in Lesotho?
Make the answer very short. 3.85e+08. What is the difference between the highest and the lowest Savings(current US$) in Uganda?
Your response must be concise. 4.56e+08. 